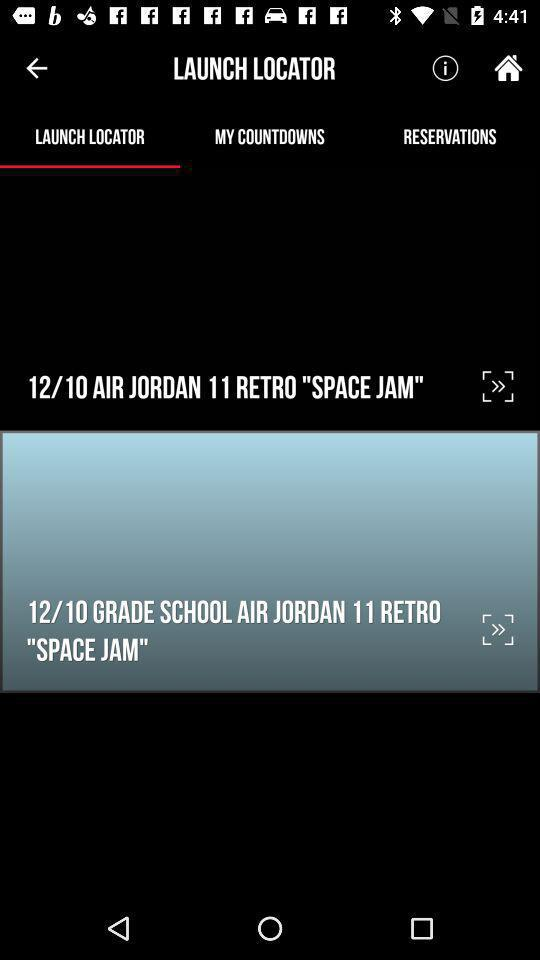When did the user create the account?
When the provided information is insufficient, respond with <no answer>. <no answer> 